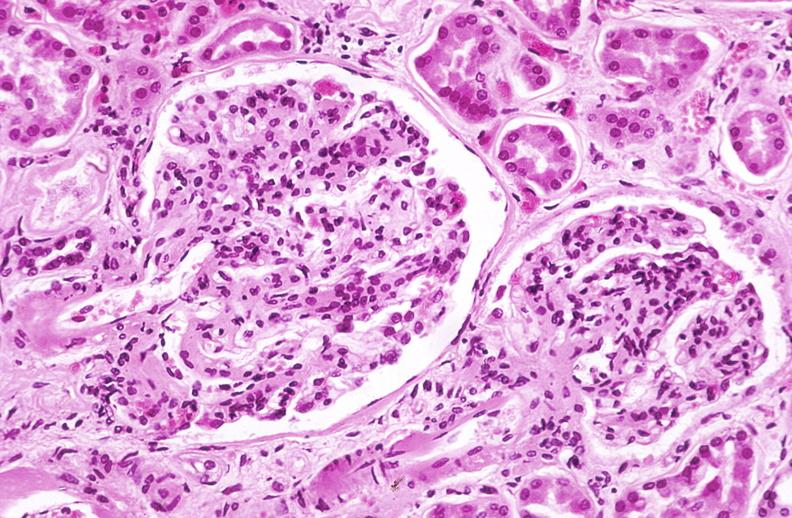does this image show kidney glomerulus, arteriolar thickening in a patient with diabetes mellitus?
Answer the question using a single word or phrase. Yes 